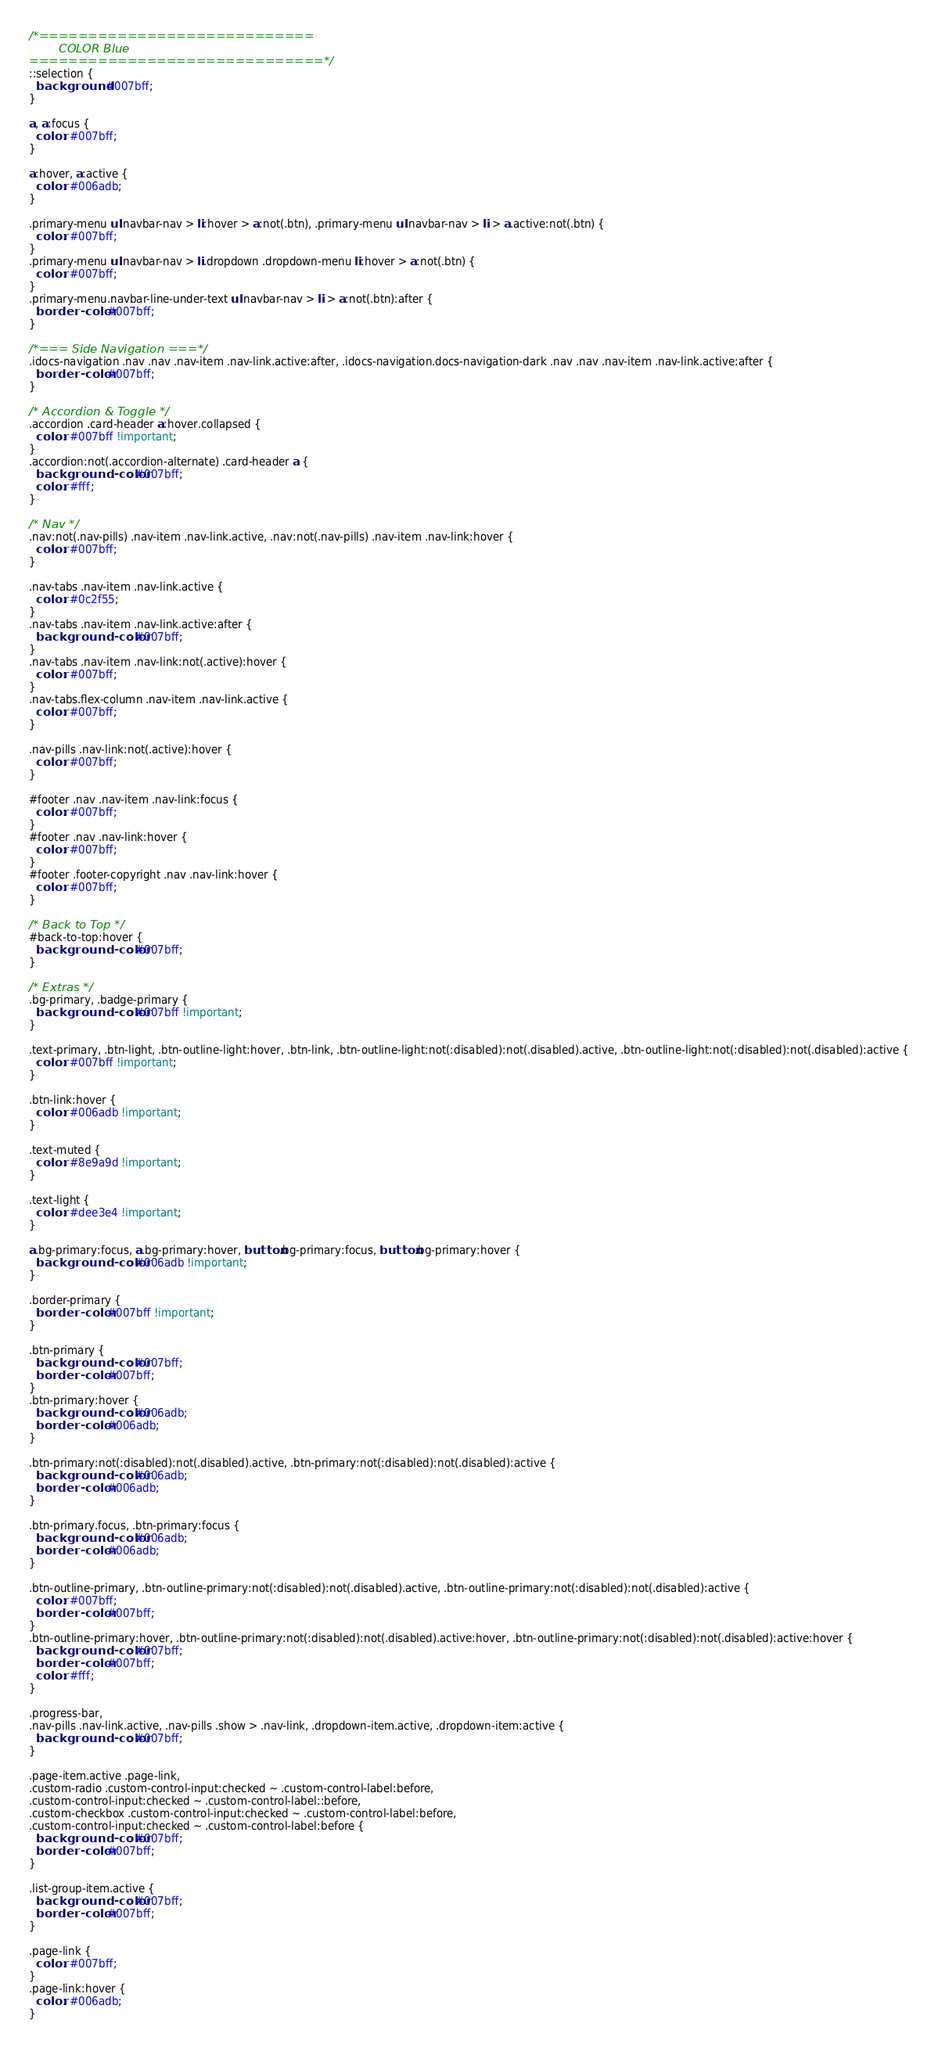Convert code to text. <code><loc_0><loc_0><loc_500><loc_500><_CSS_>/*============================
		COLOR Blue
==============================*/
::selection {
  background: #007bff;
}

a, a:focus {
  color: #007bff;
}

a:hover, a:active {
  color: #006adb;
}

.primary-menu ul.navbar-nav > li:hover > a:not(.btn), .primary-menu ul.navbar-nav > li > a.active:not(.btn) {
  color: #007bff;
}
.primary-menu ul.navbar-nav > li.dropdown .dropdown-menu li:hover > a:not(.btn) {
  color: #007bff;
}
.primary-menu.navbar-line-under-text ul.navbar-nav > li > a:not(.btn):after {
  border-color: #007bff;
}

/*=== Side Navigation ===*/
.idocs-navigation .nav .nav .nav-item .nav-link.active:after, .idocs-navigation.docs-navigation-dark .nav .nav .nav-item .nav-link.active:after {
  border-color: #007bff;
}

/* Accordion & Toggle */
.accordion .card-header a:hover.collapsed {
  color: #007bff !important;
}
.accordion:not(.accordion-alternate) .card-header a {
  background-color: #007bff;
  color: #fff;
}

/* Nav */
.nav:not(.nav-pills) .nav-item .nav-link.active, .nav:not(.nav-pills) .nav-item .nav-link:hover {
  color: #007bff;
}

.nav-tabs .nav-item .nav-link.active {
  color: #0c2f55;
}
.nav-tabs .nav-item .nav-link.active:after {
  background-color: #007bff;
}
.nav-tabs .nav-item .nav-link:not(.active):hover {
  color: #007bff;
}
.nav-tabs.flex-column .nav-item .nav-link.active {
  color: #007bff;
}

.nav-pills .nav-link:not(.active):hover {
  color: #007bff;
}

#footer .nav .nav-item .nav-link:focus {
  color: #007bff;
}
#footer .nav .nav-link:hover {
  color: #007bff;
}
#footer .footer-copyright .nav .nav-link:hover {
  color: #007bff;
}

/* Back to Top */
#back-to-top:hover {
  background-color: #007bff;
}

/* Extras */
.bg-primary, .badge-primary {
  background-color: #007bff !important;
}

.text-primary, .btn-light, .btn-outline-light:hover, .btn-link, .btn-outline-light:not(:disabled):not(.disabled).active, .btn-outline-light:not(:disabled):not(.disabled):active {
  color: #007bff !important;
}

.btn-link:hover {
  color: #006adb !important;
}

.text-muted {
  color: #8e9a9d !important;
}

.text-light {
  color: #dee3e4 !important;
}

a.bg-primary:focus, a.bg-primary:hover, button.bg-primary:focus, button.bg-primary:hover {
  background-color: #006adb !important;
}

.border-primary {
  border-color: #007bff !important;
}

.btn-primary {
  background-color: #007bff;
  border-color: #007bff;
}
.btn-primary:hover {
  background-color: #006adb;
  border-color: #006adb;
}

.btn-primary:not(:disabled):not(.disabled).active, .btn-primary:not(:disabled):not(.disabled):active {
  background-color: #006adb;
  border-color: #006adb;
}

.btn-primary.focus, .btn-primary:focus {
  background-color: #006adb;
  border-color: #006adb;
}

.btn-outline-primary, .btn-outline-primary:not(:disabled):not(.disabled).active, .btn-outline-primary:not(:disabled):not(.disabled):active {
  color: #007bff;
  border-color: #007bff;
}
.btn-outline-primary:hover, .btn-outline-primary:not(:disabled):not(.disabled).active:hover, .btn-outline-primary:not(:disabled):not(.disabled):active:hover {
  background-color: #007bff;
  border-color: #007bff;
  color: #fff;
}

.progress-bar,
.nav-pills .nav-link.active, .nav-pills .show > .nav-link, .dropdown-item.active, .dropdown-item:active {
  background-color: #007bff;
}

.page-item.active .page-link,
.custom-radio .custom-control-input:checked ~ .custom-control-label:before,
.custom-control-input:checked ~ .custom-control-label::before,
.custom-checkbox .custom-control-input:checked ~ .custom-control-label:before,
.custom-control-input:checked ~ .custom-control-label:before {
  background-color: #007bff;
  border-color: #007bff;
}

.list-group-item.active {
  background-color: #007bff;
  border-color: #007bff;
}

.page-link {
  color: #007bff;
}
.page-link:hover {
  color: #006adb;
}
</code> 